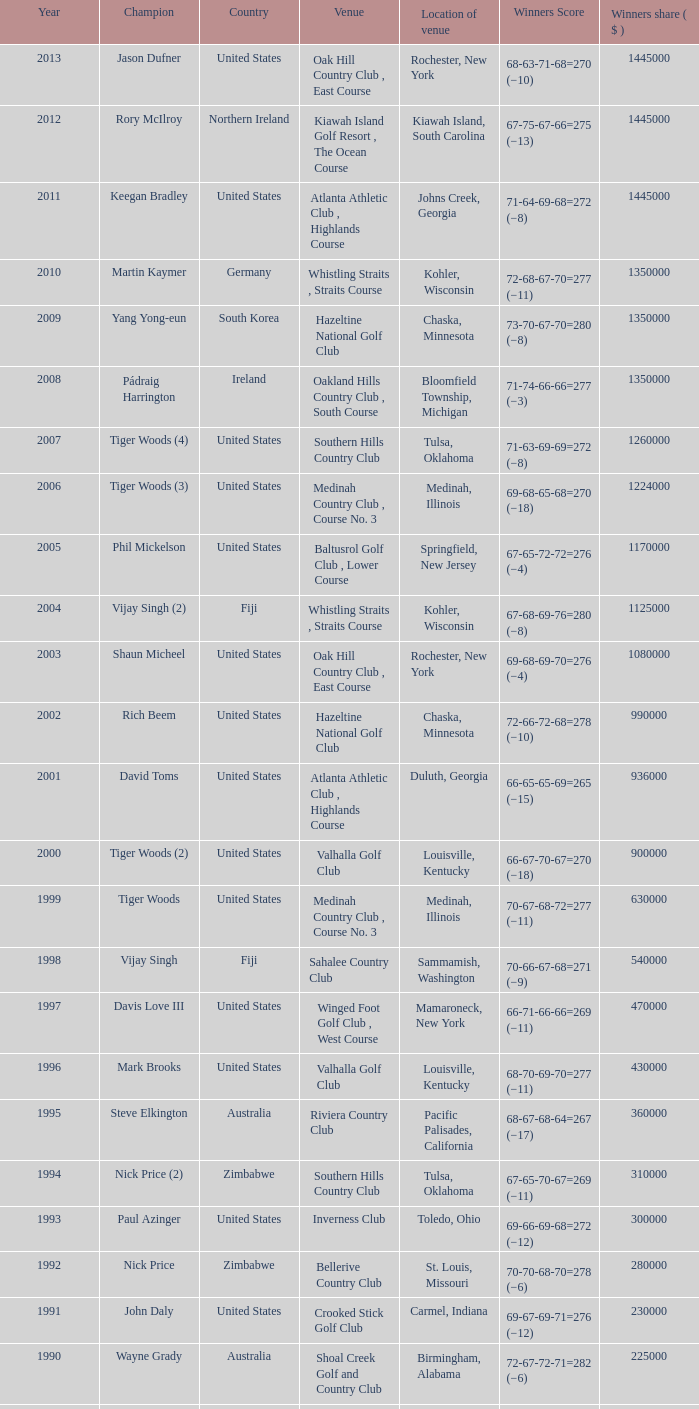List all winning scores from 1982. 63-69-68-72=272 (−8). 